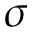Convert formula to latex. <formula><loc_0><loc_0><loc_500><loc_500>\sigma</formula> 